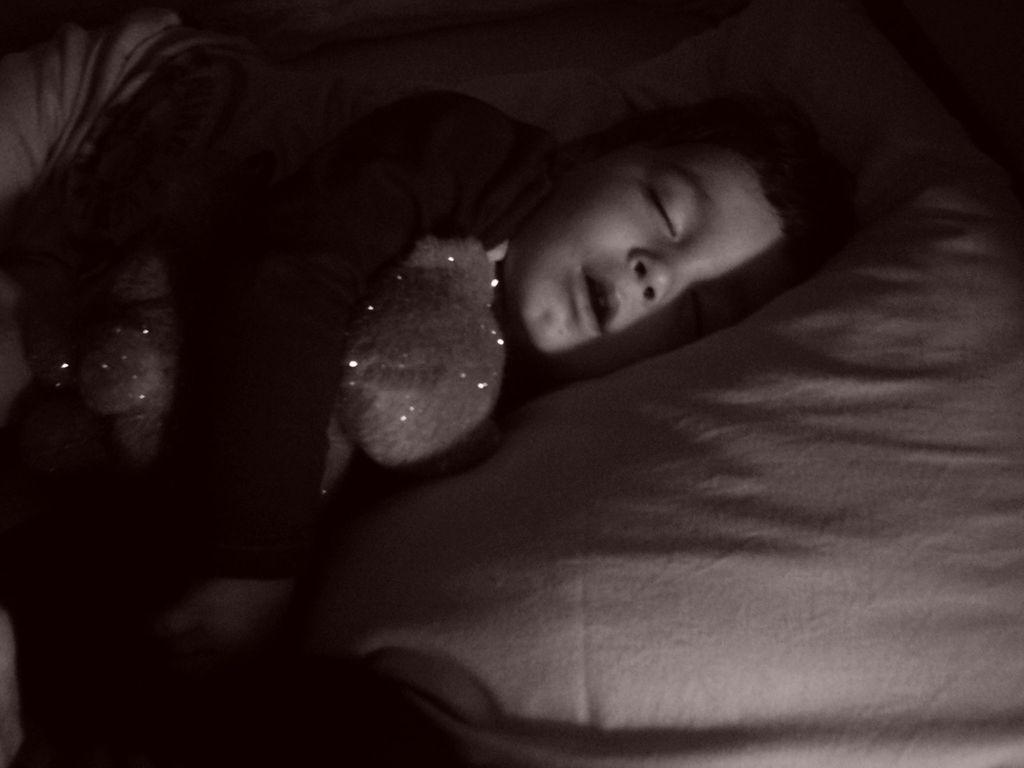What is the color scheme of the image? The image is black and white. Who is present in the image? There is a boy in the image. What is the boy doing in the image? The boy is sleeping on a bed. What is the boy holding in the image? The boy is holding a doll. What type of chin can be seen on the boy's doll in the image? There is no chin visible on the doll in the image, as it is not mentioned in the provided facts and the image is in black and white, making it difficult to discern such details. 